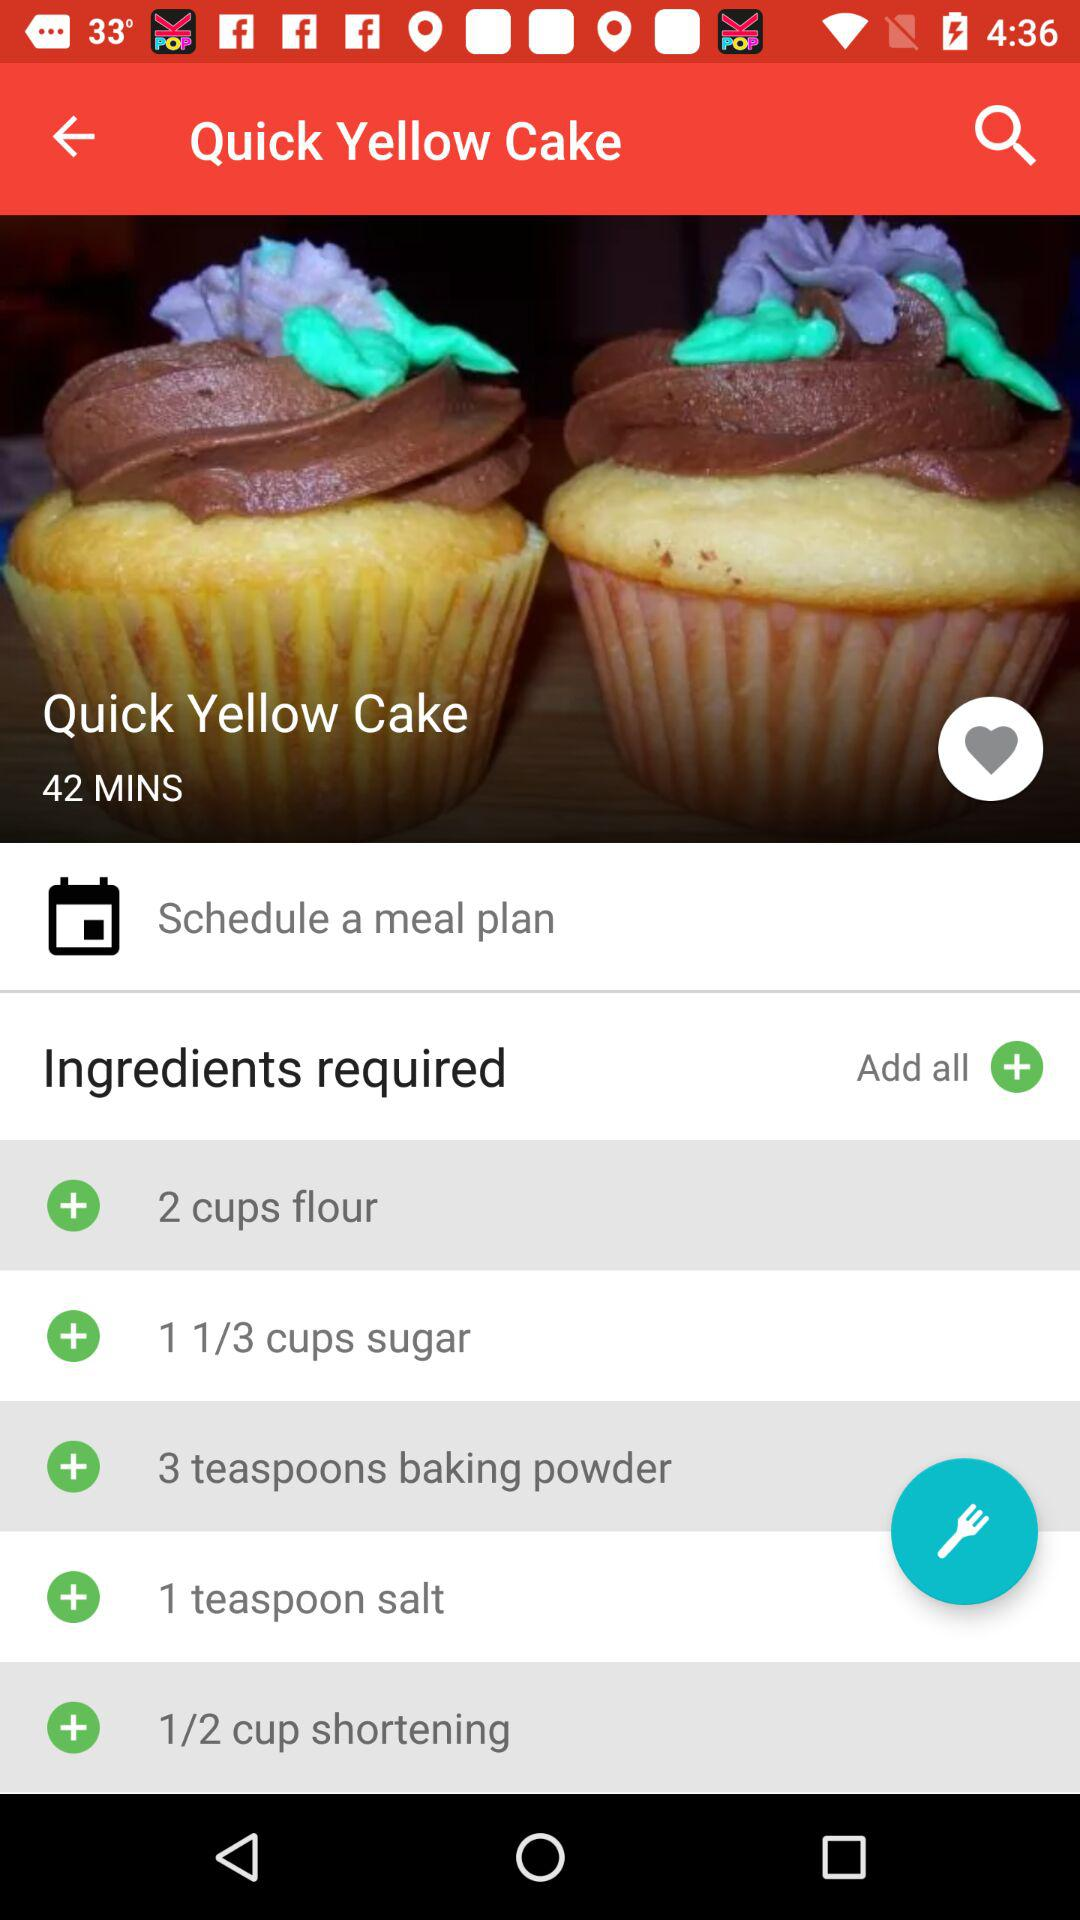What is the dish name? The dish name is "Quick Yellow Cake". 